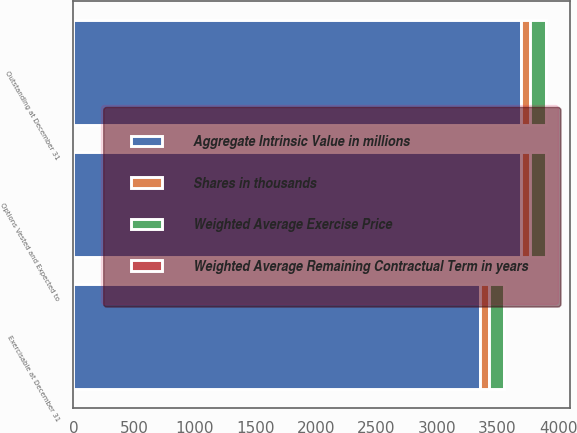Convert chart. <chart><loc_0><loc_0><loc_500><loc_500><stacked_bar_chart><ecel><fcel>Outstanding at December 31<fcel>Options Vested and Expected to<fcel>Exercisable at December 31<nl><fcel>Aggregate Intrinsic Value in millions<fcel>3691<fcel>3691<fcel>3356<nl><fcel>Shares in thousands<fcel>75.07<fcel>75.07<fcel>74.2<nl><fcel>Weighted Average Remaining Contractual Term in years<fcel>2.85<fcel>2.85<fcel>2.35<nl><fcel>Weighted Average Exercise Price<fcel>133<fcel>133<fcel>124<nl></chart> 